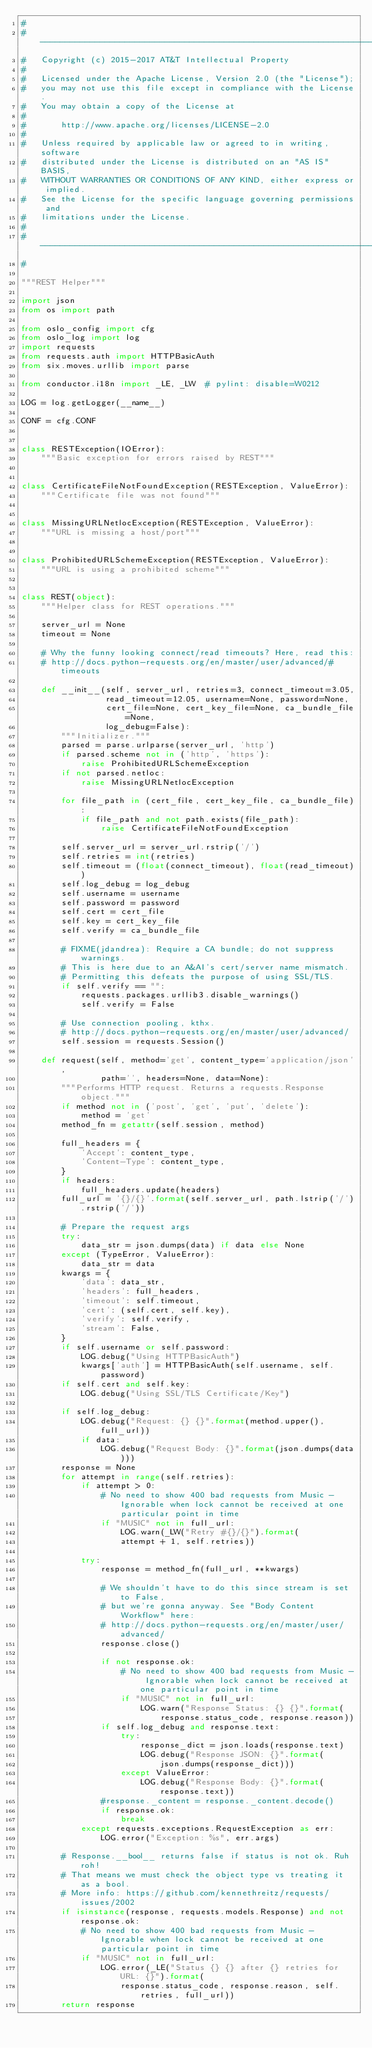Convert code to text. <code><loc_0><loc_0><loc_500><loc_500><_Python_>#
# -------------------------------------------------------------------------
#   Copyright (c) 2015-2017 AT&T Intellectual Property
#
#   Licensed under the Apache License, Version 2.0 (the "License");
#   you may not use this file except in compliance with the License.
#   You may obtain a copy of the License at
#
#       http://www.apache.org/licenses/LICENSE-2.0
#
#   Unless required by applicable law or agreed to in writing, software
#   distributed under the License is distributed on an "AS IS" BASIS,
#   WITHOUT WARRANTIES OR CONDITIONS OF ANY KIND, either express or implied.
#   See the License for the specific language governing permissions and
#   limitations under the License.
#
# -------------------------------------------------------------------------
#

"""REST Helper"""

import json
from os import path

from oslo_config import cfg
from oslo_log import log
import requests
from requests.auth import HTTPBasicAuth
from six.moves.urllib import parse

from conductor.i18n import _LE, _LW  # pylint: disable=W0212

LOG = log.getLogger(__name__)

CONF = cfg.CONF


class RESTException(IOError):
    """Basic exception for errors raised by REST"""


class CertificateFileNotFoundException(RESTException, ValueError):
    """Certificate file was not found"""


class MissingURLNetlocException(RESTException, ValueError):
    """URL is missing a host/port"""


class ProhibitedURLSchemeException(RESTException, ValueError):
    """URL is using a prohibited scheme"""


class REST(object):
    """Helper class for REST operations."""

    server_url = None
    timeout = None

    # Why the funny looking connect/read timeouts? Here, read this:
    # http://docs.python-requests.org/en/master/user/advanced/#timeouts

    def __init__(self, server_url, retries=3, connect_timeout=3.05,
                 read_timeout=12.05, username=None, password=None,
                 cert_file=None, cert_key_file=None, ca_bundle_file=None,
                 log_debug=False):
        """Initializer."""
        parsed = parse.urlparse(server_url, 'http')
        if parsed.scheme not in ('http', 'https'):
            raise ProhibitedURLSchemeException
        if not parsed.netloc:
            raise MissingURLNetlocException

        for file_path in (cert_file, cert_key_file, ca_bundle_file):
            if file_path and not path.exists(file_path):
                raise CertificateFileNotFoundException

        self.server_url = server_url.rstrip('/')
        self.retries = int(retries)
        self.timeout = (float(connect_timeout), float(read_timeout))
        self.log_debug = log_debug
        self.username = username
        self.password = password
        self.cert = cert_file
        self.key = cert_key_file
        self.verify = ca_bundle_file

        # FIXME(jdandrea): Require a CA bundle; do not suppress warnings.
        # This is here due to an A&AI's cert/server name mismatch.
        # Permitting this defeats the purpose of using SSL/TLS.
        if self.verify == "":
            requests.packages.urllib3.disable_warnings()
            self.verify = False

        # Use connection pooling, kthx.
        # http://docs.python-requests.org/en/master/user/advanced/
        self.session = requests.Session()

    def request(self, method='get', content_type='application/json',
                path='', headers=None, data=None):
        """Performs HTTP request. Returns a requests.Response object."""
        if method not in ('post', 'get', 'put', 'delete'):
            method = 'get'
        method_fn = getattr(self.session, method)

        full_headers = {
            'Accept': content_type,
            'Content-Type': content_type,
        }
        if headers:
            full_headers.update(headers)
        full_url = '{}/{}'.format(self.server_url, path.lstrip('/').rstrip('/'))

        # Prepare the request args
        try:
            data_str = json.dumps(data) if data else None
        except (TypeError, ValueError):
            data_str = data
        kwargs = {
            'data': data_str,
            'headers': full_headers,
            'timeout': self.timeout,
            'cert': (self.cert, self.key),
            'verify': self.verify,
            'stream': False,
        }
        if self.username or self.password:
            LOG.debug("Using HTTPBasicAuth")
            kwargs['auth'] = HTTPBasicAuth(self.username, self.password)
        if self.cert and self.key:
            LOG.debug("Using SSL/TLS Certificate/Key")

        if self.log_debug:
            LOG.debug("Request: {} {}".format(method.upper(), full_url))
            if data:
                LOG.debug("Request Body: {}".format(json.dumps(data)))
        response = None
        for attempt in range(self.retries):
            if attempt > 0:
                # No need to show 400 bad requests from Music - Ignorable when lock cannot be received at one particular point in time
                if "MUSIC" not in full_url:
                    LOG.warn(_LW("Retry #{}/{}").format(
                    attempt + 1, self.retries))

            try:
                response = method_fn(full_url, **kwargs)

                # We shouldn't have to do this since stream is set to False,
                # but we're gonna anyway. See "Body Content Workflow" here:
                # http://docs.python-requests.org/en/master/user/advanced/
                response.close()

                if not response.ok:
                    # No need to show 400 bad requests from Music - Ignorable when lock cannot be received at one particular point in time
                    if "MUSIC" not in full_url:
                        LOG.warn("Response Status: {} {}".format(
                            response.status_code, response.reason))
                if self.log_debug and response.text:
                    try:
                        response_dict = json.loads(response.text)
                        LOG.debug("Response JSON: {}".format(
                            json.dumps(response_dict)))
                    except ValueError:
                        LOG.debug("Response Body: {}".format(response.text))
                #response._content = response._content.decode()
                if response.ok:
                    break
            except requests.exceptions.RequestException as err:
                LOG.error("Exception: %s", err.args)

        # Response.__bool__ returns false if status is not ok. Ruh roh!
        # That means we must check the object type vs treating it as a bool.
        # More info: https://github.com/kennethreitz/requests/issues/2002
        if isinstance(response, requests.models.Response) and not response.ok:
            # No need to show 400 bad requests from Music - Ignorable when lock cannot be received at one particular point in time
            if "MUSIC" not in full_url:
                LOG.error(_LE("Status {} {} after {} retries for URL: {}").format(
                    response.status_code, response.reason, self.retries, full_url))
        return response
</code> 